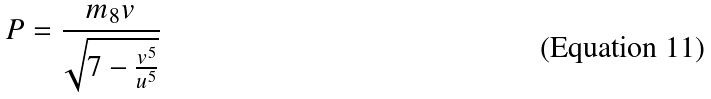Convert formula to latex. <formula><loc_0><loc_0><loc_500><loc_500>P = \frac { m _ { 8 } v } { \sqrt { 7 - \frac { v ^ { 5 } } { u ^ { 5 } } } }</formula> 